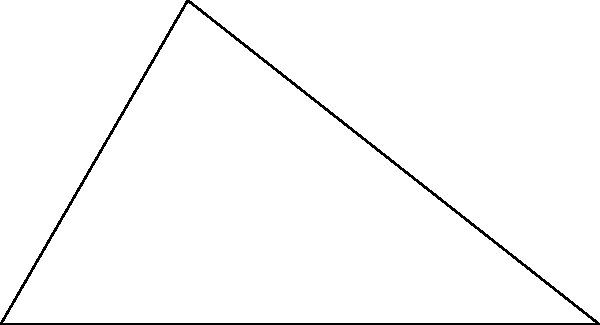As part of a land surveying project in Tirana, you need to determine the dimensions of a triangular plot. Given that one side of the plot is 12 meters long, another side is 7 meters long, and the angle between these two sides is 37°, calculate the length of the third side of the plot to the nearest centimeter. Let's approach this step-by-step using the law of cosines:

1) Let's denote the sides of the triangle as follows:
   a = 12 m (given)
   b = 7 m (given)
   c = the side we need to calculate
   θ = 37° (the angle between a and b)

2) The law of cosines states:
   $c^2 = a^2 + b^2 - 2ab \cos(θ)$

3) Let's substitute our known values:
   $c^2 = 12^2 + 7^2 - 2(12)(7) \cos(37°)$

4) Simplify:
   $c^2 = 144 + 49 - 168 \cos(37°)$

5) Calculate $\cos(37°)$ ≈ 0.7986

6) Substitute this value:
   $c^2 = 144 + 49 - 168(0.7986) = 58.3352$

7) Take the square root of both sides:
   $c = \sqrt{58.3352} ≈ 7.6377$ m

8) Rounding to the nearest centimeter:
   c ≈ 7.64 m
Answer: 7.64 m 